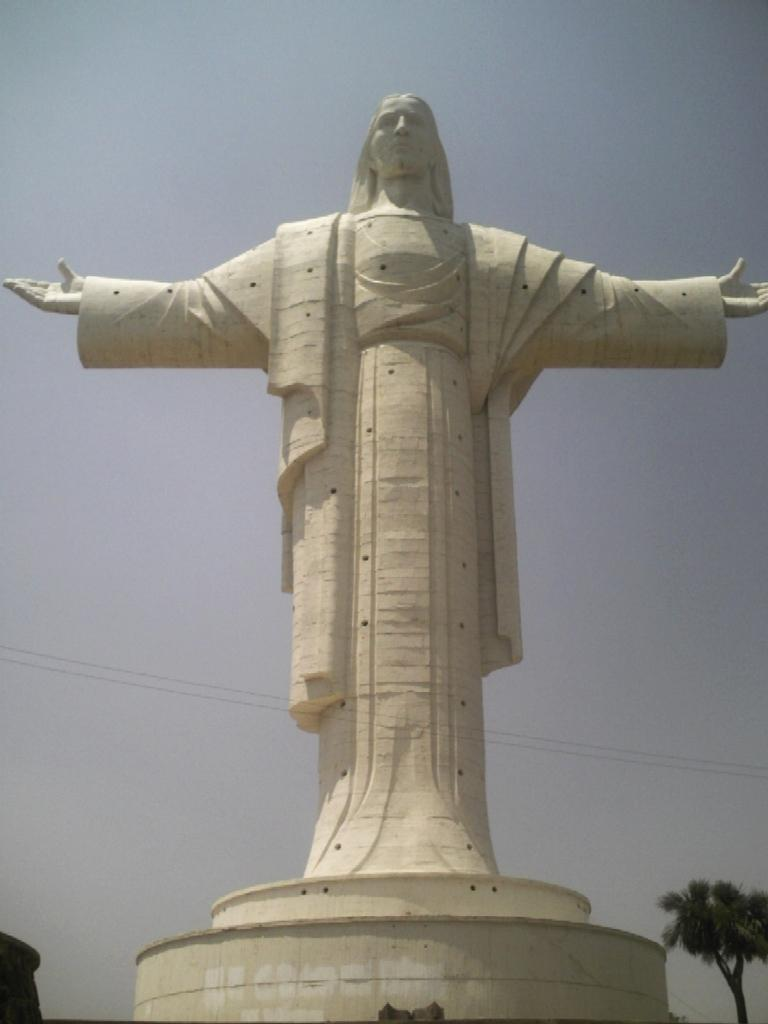What is the main subject of the image? There is a statue of a man in the image. What is the color of the statue? The statue is white in color. What can be seen on the right side of the image? There is a tree on the right side of the image. What is visible at the top of the image? The sky is visible at the top of the image. How much rice is being served on the statue's plate in the image? There is no rice or plate present in the image; it features a statue of a man. What angle is the statue leaning at in the image? The statue is not leaning at any angle in the image; it is standing upright. 